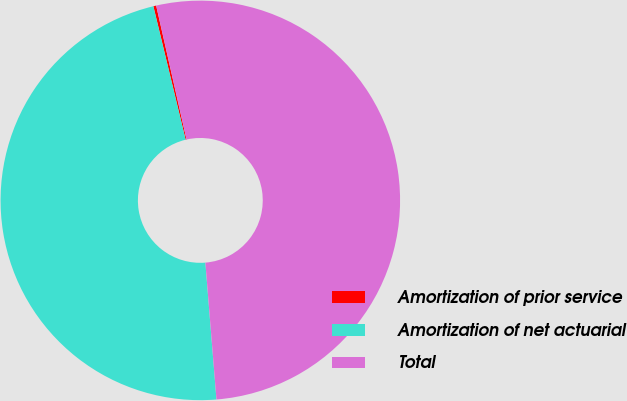<chart> <loc_0><loc_0><loc_500><loc_500><pie_chart><fcel>Amortization of prior service<fcel>Amortization of net actuarial<fcel>Total<nl><fcel>0.23%<fcel>47.51%<fcel>52.26%<nl></chart> 